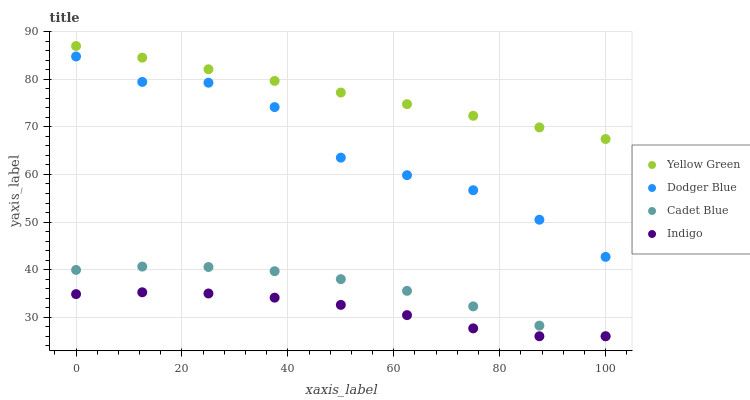Does Indigo have the minimum area under the curve?
Answer yes or no. Yes. Does Yellow Green have the maximum area under the curve?
Answer yes or no. Yes. Does Cadet Blue have the minimum area under the curve?
Answer yes or no. No. Does Cadet Blue have the maximum area under the curve?
Answer yes or no. No. Is Yellow Green the smoothest?
Answer yes or no. Yes. Is Dodger Blue the roughest?
Answer yes or no. Yes. Is Cadet Blue the smoothest?
Answer yes or no. No. Is Cadet Blue the roughest?
Answer yes or no. No. Does Indigo have the lowest value?
Answer yes or no. Yes. Does Dodger Blue have the lowest value?
Answer yes or no. No. Does Yellow Green have the highest value?
Answer yes or no. Yes. Does Cadet Blue have the highest value?
Answer yes or no. No. Is Dodger Blue less than Yellow Green?
Answer yes or no. Yes. Is Yellow Green greater than Cadet Blue?
Answer yes or no. Yes. Does Indigo intersect Cadet Blue?
Answer yes or no. Yes. Is Indigo less than Cadet Blue?
Answer yes or no. No. Is Indigo greater than Cadet Blue?
Answer yes or no. No. Does Dodger Blue intersect Yellow Green?
Answer yes or no. No. 